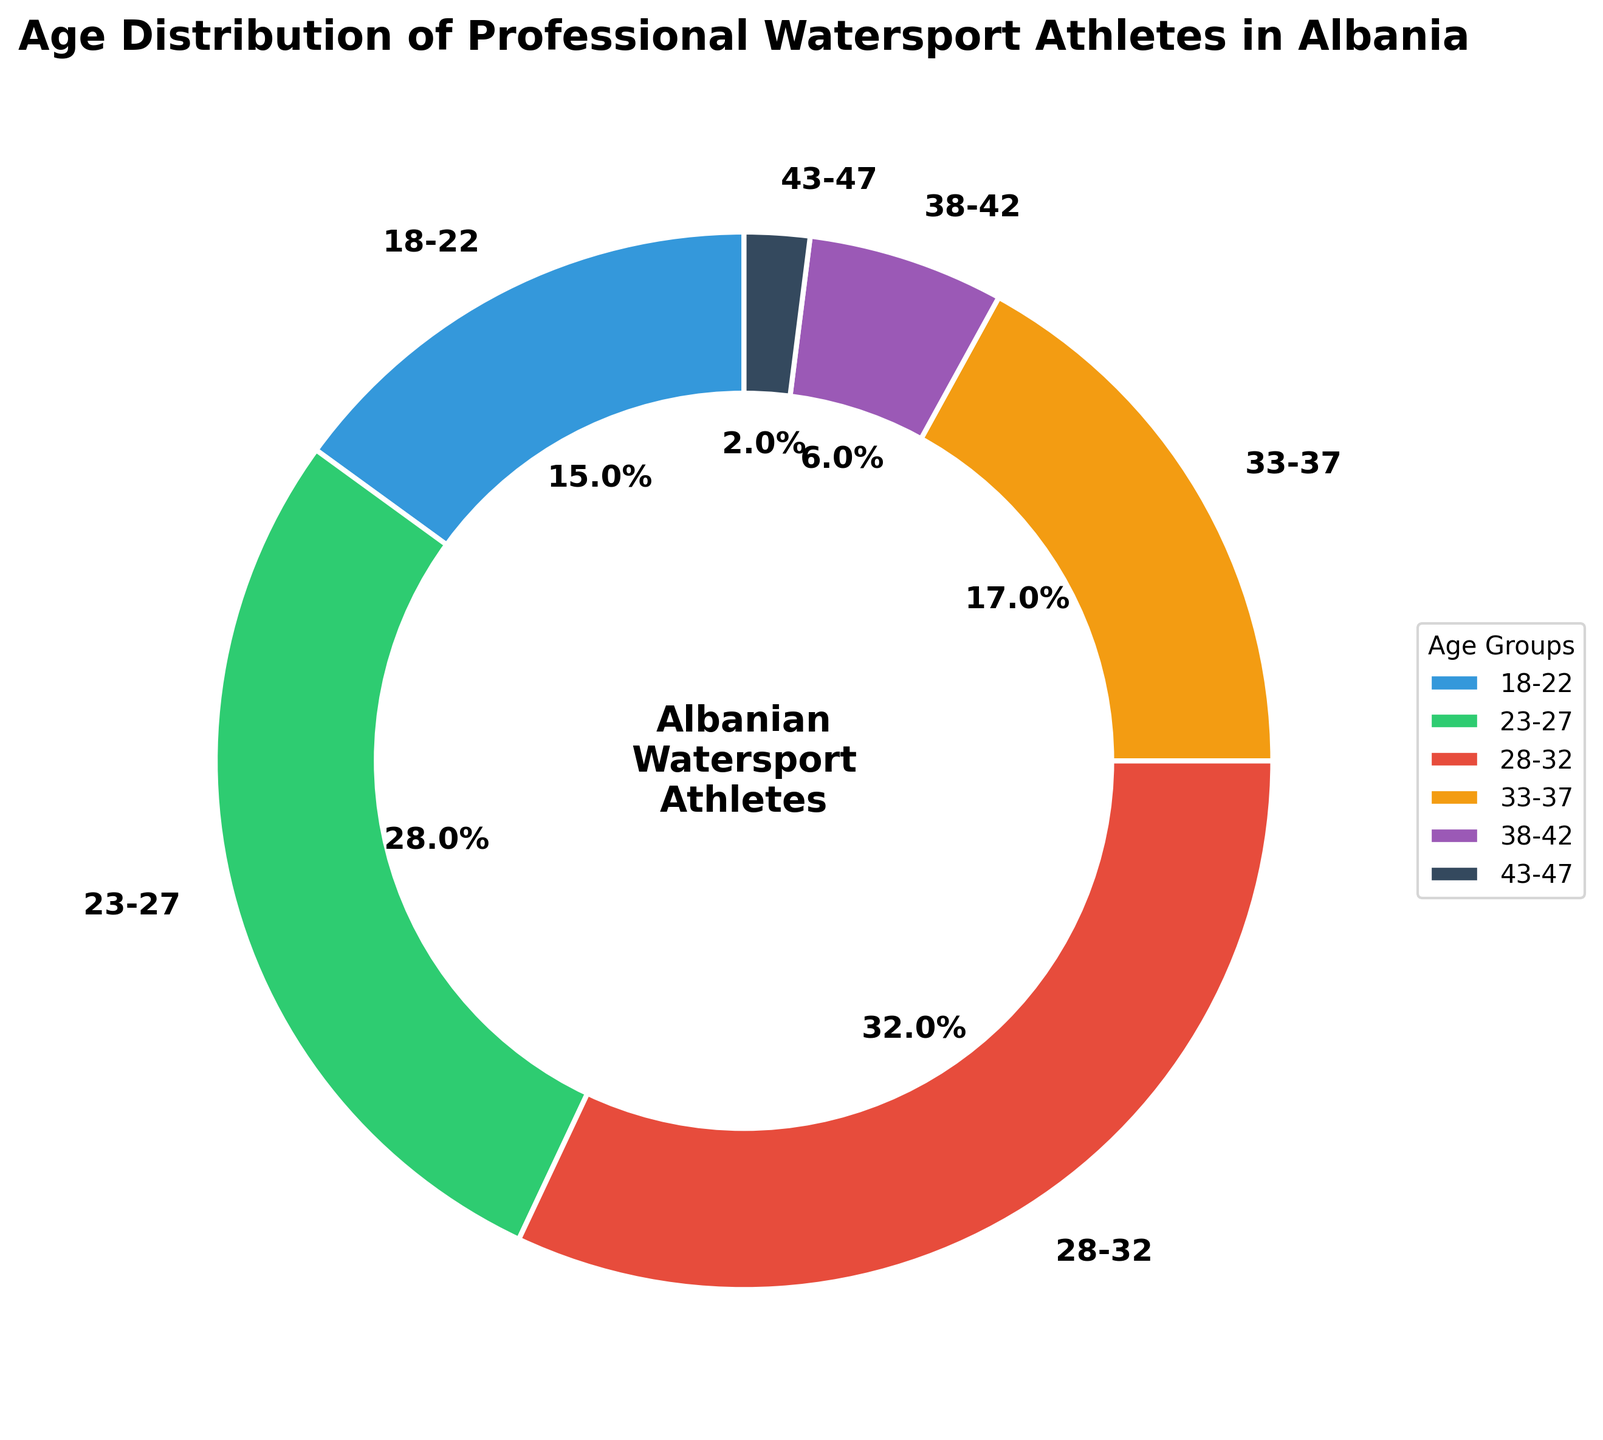```plaintext
What is the largest age group among professional watersport athletes in Albania? The largest age group is represented by the largest slice of the pie chart, which covers the highest percentage. In this chart, the 28-32 age group has the largest slice with 32%.
Answer: 28-32 Which age group has the smallest representation in the chart? The smallest age group is the one with the smallest percentage in the pie chart. Here, the 43-47 age group is the smallest with 2%.
Answer: 43-47 How does the percentage of athletes aged 23-27 compare to those aged 38-42? To compare, we look at the percentages for these age groups. The 23-27 age group has 28%, whereas the 38-42 age group has 6%. Hence, there are more athletes aged 23-27 than those aged 38-42.
Answer: 23-27 has more What is the combined percentage of athletes aged 33-37 and 38-42? To find the combined percentage, we add the percentages of these age groups: 17% + 6% = 23%.
Answer: 23% Is the percentage of athletes aged 18-22 less than 20%? We check the percentage for the 18-22 age group, which is 15%, and see that it is less than 20%.
Answer: Yes Which two age groups together account for more than half of the athletes? We need to find two age groups whose combined percentage is more than 50%. The groups 23-27 and 28-32 have 28% and 32% respectively. Adding these gives 28% + 32% = 60%, which is more than half.
Answer: 23-27 and 28-32 What color represents the age group 33-37 in the pie chart? The age group 33-37 is represented by the color that corresponds to its slice in the pie chart. This slice is colored in a shade of yellow.
Answer: Yellow Which age groups have percentages represented by a two-digit number? Age groups with two-digit percentage values are those that lie between 10% and 99%. These groups are 18-22 (15%), 23-27 (28%), 28-32 (32%), and 33-37 (17%).
Answer: 18-22, 23-27, 28-32, 33-37 What is the difference in percentage between the 28-32 and 18-22 age groups? We calculate the difference by subtracting the smaller percentage from the larger one: 32% - 15% = 17%.
Answer: 17%
``` 